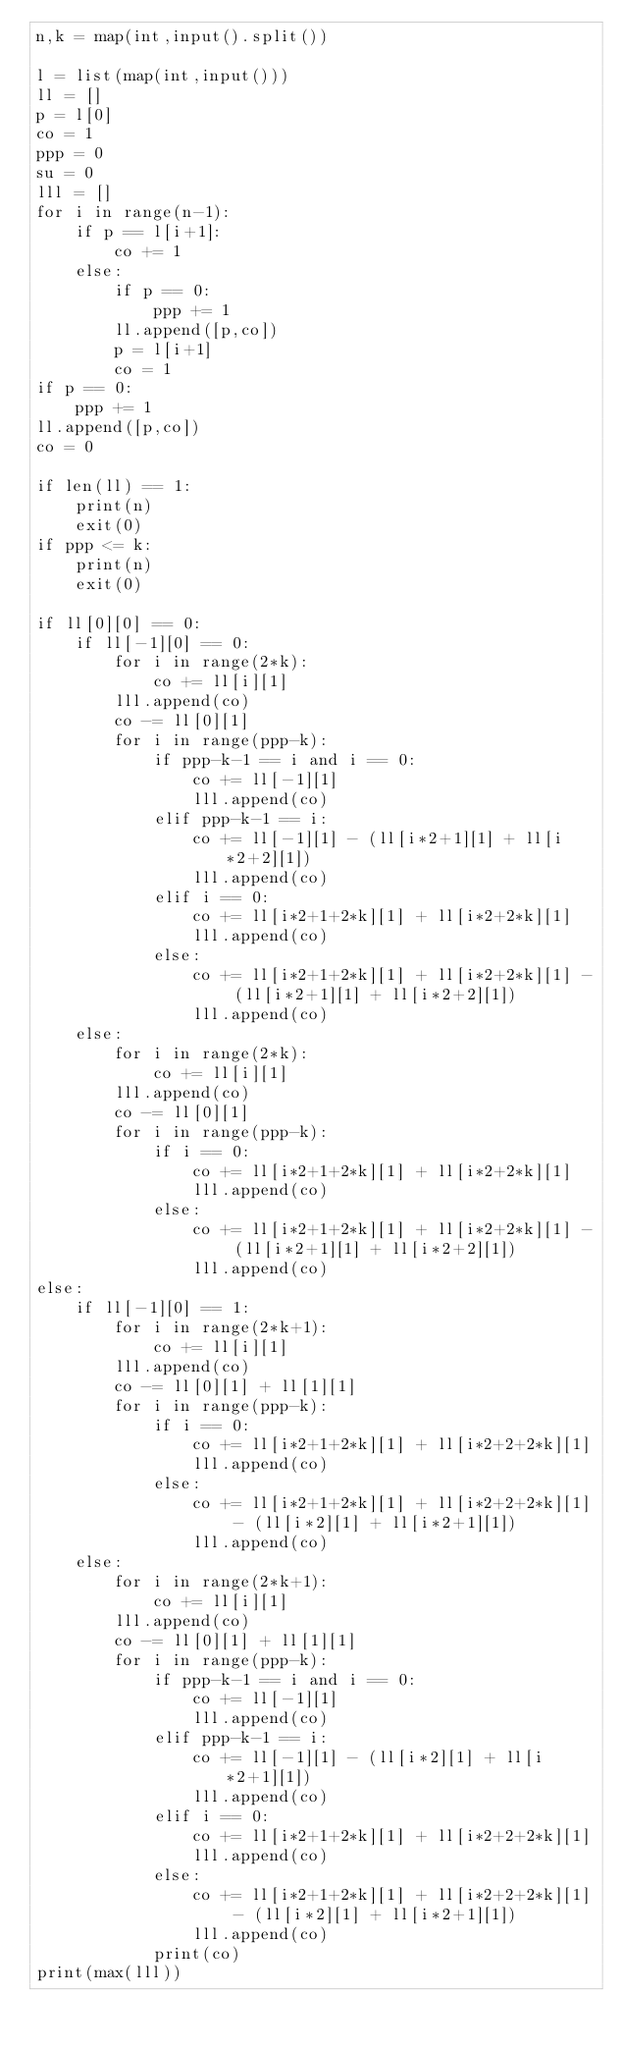<code> <loc_0><loc_0><loc_500><loc_500><_Python_>n,k = map(int,input().split())

l = list(map(int,input()))
ll = []
p = l[0]
co = 1
ppp = 0
su = 0
lll = []
for i in range(n-1):
    if p == l[i+1]:
        co += 1
    else:
        if p == 0:
            ppp += 1
        ll.append([p,co])
        p = l[i+1]
        co = 1
if p == 0:
    ppp += 1
ll.append([p,co])
co = 0

if len(ll) == 1:
    print(n)
    exit(0)
if ppp <= k:
    print(n)
    exit(0)

if ll[0][0] == 0:
    if ll[-1][0] == 0:
        for i in range(2*k):
            co += ll[i][1]
        lll.append(co)
        co -= ll[0][1]
        for i in range(ppp-k):
            if ppp-k-1 == i and i == 0:
                co += ll[-1][1]
                lll.append(co)
            elif ppp-k-1 == i:
                co += ll[-1][1] - (ll[i*2+1][1] + ll[i*2+2][1])
                lll.append(co)
            elif i == 0:
                co += ll[i*2+1+2*k][1] + ll[i*2+2*k][1]
                lll.append(co)
            else:
                co += ll[i*2+1+2*k][1] + ll[i*2+2*k][1] - (ll[i*2+1][1] + ll[i*2+2][1])
                lll.append(co)
    else:
        for i in range(2*k):
            co += ll[i][1]
        lll.append(co)
        co -= ll[0][1]
        for i in range(ppp-k):
            if i == 0:
                co += ll[i*2+1+2*k][1] + ll[i*2+2*k][1]
                lll.append(co)
            else:
                co += ll[i*2+1+2*k][1] + ll[i*2+2*k][1] - (ll[i*2+1][1] + ll[i*2+2][1])
                lll.append(co)
else:
    if ll[-1][0] == 1:
        for i in range(2*k+1):
            co += ll[i][1]
        lll.append(co)
        co -= ll[0][1] + ll[1][1]
        for i in range(ppp-k):
            if i == 0:
                co += ll[i*2+1+2*k][1] + ll[i*2+2+2*k][1]
                lll.append(co)
            else:
                co += ll[i*2+1+2*k][1] + ll[i*2+2+2*k][1] - (ll[i*2][1] + ll[i*2+1][1])
                lll.append(co)
    else:
        for i in range(2*k+1):
            co += ll[i][1]
        lll.append(co)
        co -= ll[0][1] + ll[1][1]
        for i in range(ppp-k):
            if ppp-k-1 == i and i == 0:
                co += ll[-1][1]
                lll.append(co)
            elif ppp-k-1 == i:
                co += ll[-1][1] - (ll[i*2][1] + ll[i*2+1][1])
                lll.append(co)
            elif i == 0:
                co += ll[i*2+1+2*k][1] + ll[i*2+2+2*k][1]
                lll.append(co)
            else:
                co += ll[i*2+1+2*k][1] + ll[i*2+2+2*k][1] - (ll[i*2][1] + ll[i*2+1][1])
                lll.append(co)
            print(co)
print(max(lll))

</code> 